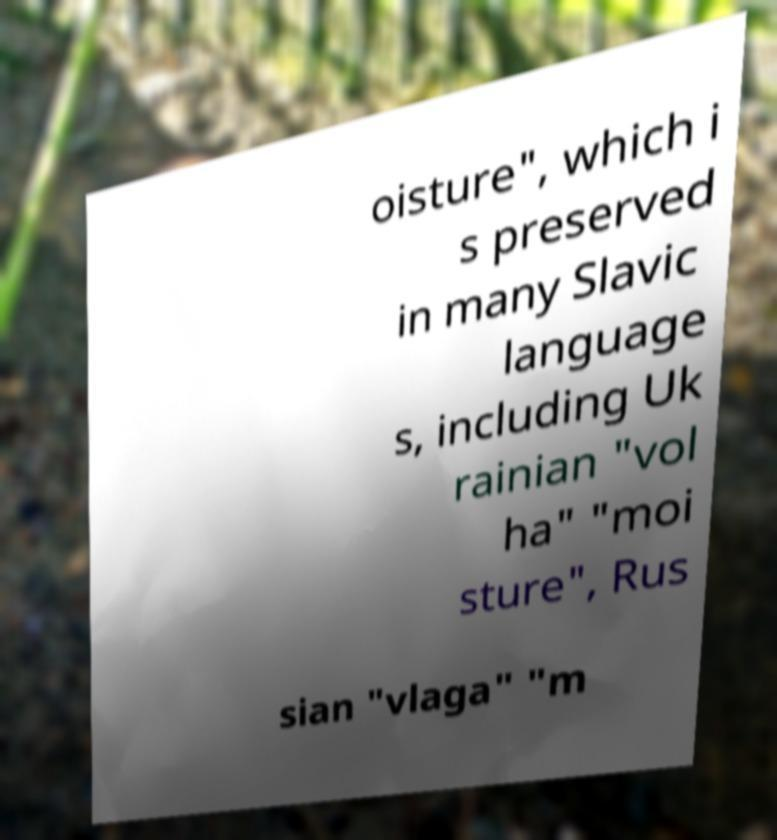Can you read and provide the text displayed in the image?This photo seems to have some interesting text. Can you extract and type it out for me? oisture", which i s preserved in many Slavic language s, including Uk rainian "vol ha" "moi sture", Rus sian "vlaga" "m 